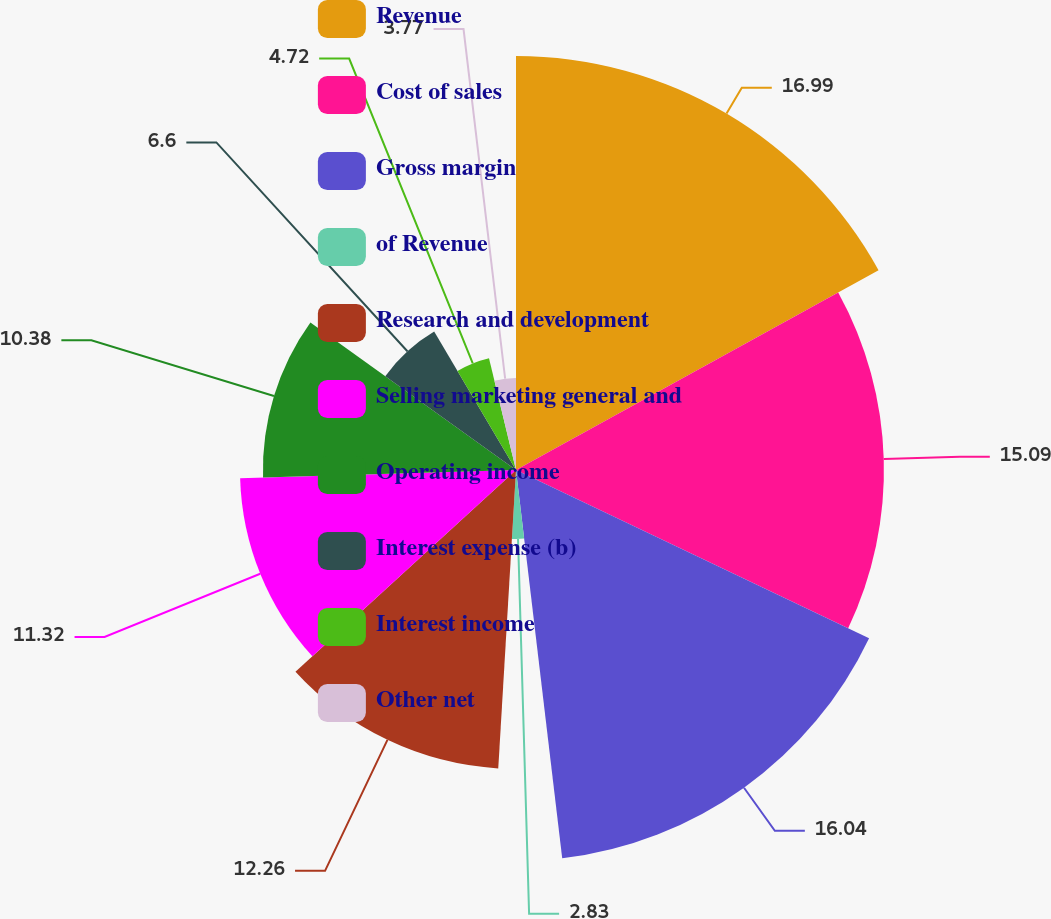<chart> <loc_0><loc_0><loc_500><loc_500><pie_chart><fcel>Revenue<fcel>Cost of sales<fcel>Gross margin<fcel>of Revenue<fcel>Research and development<fcel>Selling marketing general and<fcel>Operating income<fcel>Interest expense (b)<fcel>Interest income<fcel>Other net<nl><fcel>16.98%<fcel>15.09%<fcel>16.04%<fcel>2.83%<fcel>12.26%<fcel>11.32%<fcel>10.38%<fcel>6.6%<fcel>4.72%<fcel>3.77%<nl></chart> 